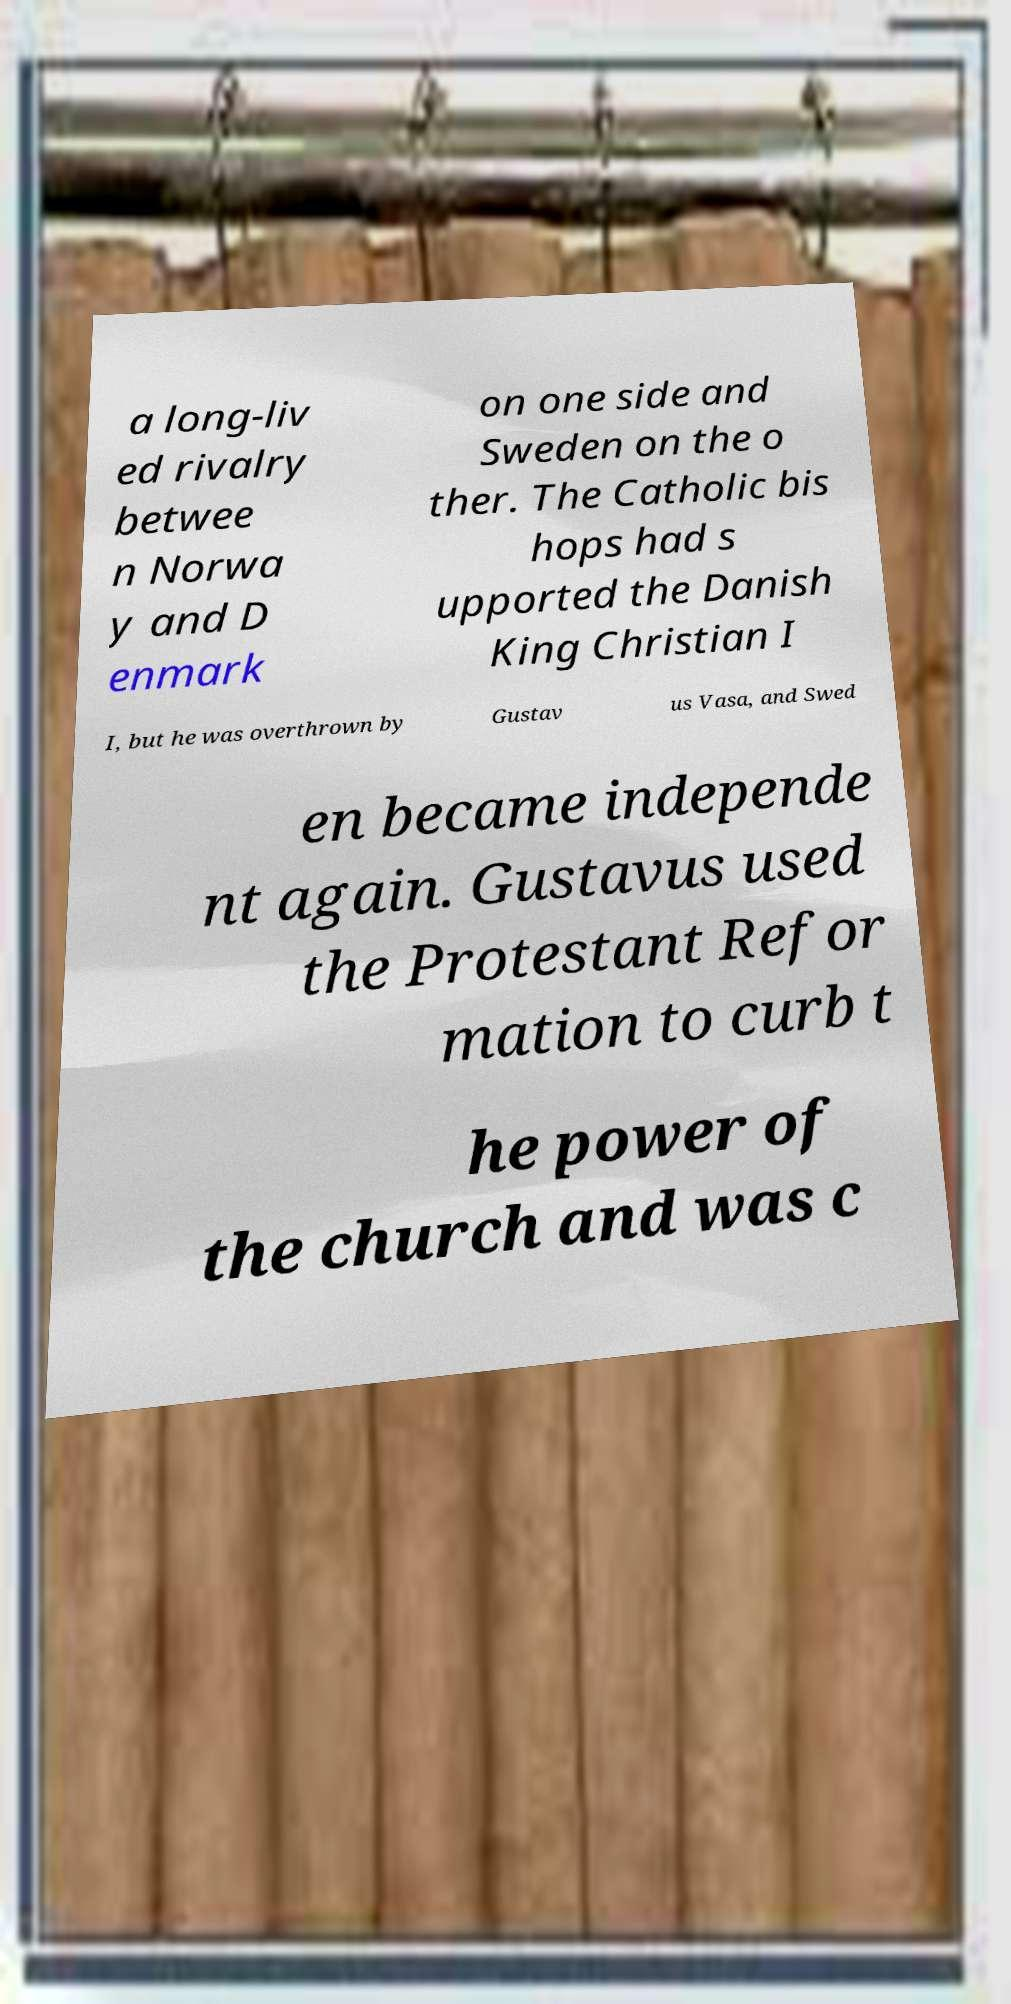Could you assist in decoding the text presented in this image and type it out clearly? a long-liv ed rivalry betwee n Norwa y and D enmark on one side and Sweden on the o ther. The Catholic bis hops had s upported the Danish King Christian I I, but he was overthrown by Gustav us Vasa, and Swed en became independe nt again. Gustavus used the Protestant Refor mation to curb t he power of the church and was c 